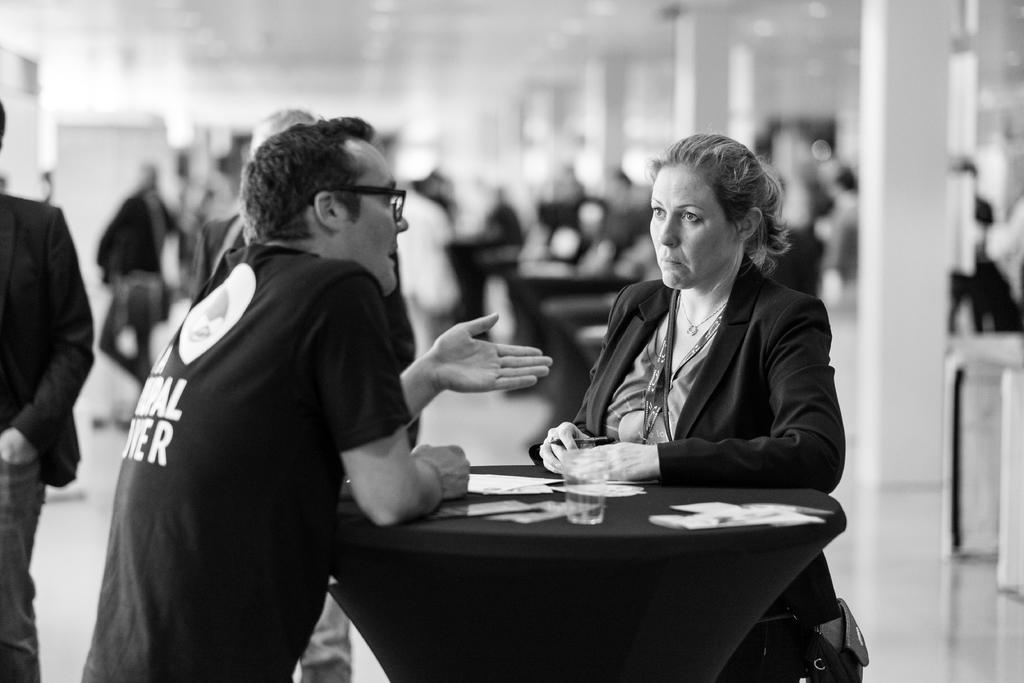Could you give a brief overview of what you see in this image? In this picture there is a man and a woman standing opposite to each other on either side of the table on which paper, glasses were placed. Man is wearing spectacles. In the background there are some people walking here. 